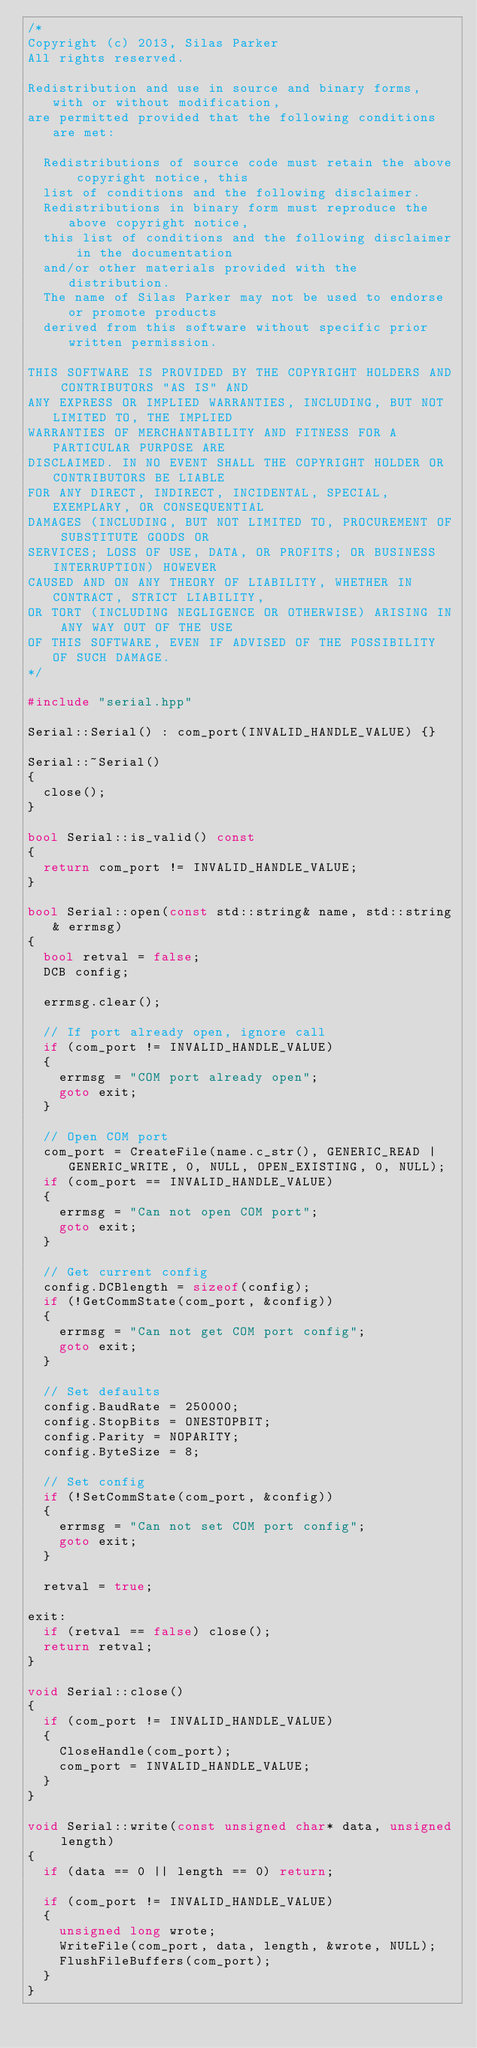Convert code to text. <code><loc_0><loc_0><loc_500><loc_500><_C++_>/*
Copyright (c) 2013, Silas Parker
All rights reserved.

Redistribution and use in source and binary forms, with or without modification,
are permitted provided that the following conditions are met:

	Redistributions of source code must retain the above copyright notice, this
	list of conditions and the following disclaimer.
	Redistributions in binary form must reproduce the above copyright notice,
	this list of conditions and the following disclaimer in the documentation
	and/or other materials provided with the distribution.
	The name of Silas Parker may not be used to endorse or promote products
	derived from this software without specific prior written permission.

THIS SOFTWARE IS PROVIDED BY THE COPYRIGHT HOLDERS AND CONTRIBUTORS "AS IS" AND
ANY EXPRESS OR IMPLIED WARRANTIES, INCLUDING, BUT NOT LIMITED TO, THE IMPLIED
WARRANTIES OF MERCHANTABILITY AND FITNESS FOR A PARTICULAR PURPOSE ARE
DISCLAIMED. IN NO EVENT SHALL THE COPYRIGHT HOLDER OR CONTRIBUTORS BE LIABLE
FOR ANY DIRECT, INDIRECT, INCIDENTAL, SPECIAL, EXEMPLARY, OR CONSEQUENTIAL
DAMAGES (INCLUDING, BUT NOT LIMITED TO, PROCUREMENT OF SUBSTITUTE GOODS OR
SERVICES; LOSS OF USE, DATA, OR PROFITS; OR BUSINESS INTERRUPTION) HOWEVER
CAUSED AND ON ANY THEORY OF LIABILITY, WHETHER IN CONTRACT, STRICT LIABILITY,
OR TORT (INCLUDING NEGLIGENCE OR OTHERWISE) ARISING IN ANY WAY OUT OF THE USE
OF THIS SOFTWARE, EVEN IF ADVISED OF THE POSSIBILITY OF SUCH DAMAGE.
*/

#include "serial.hpp"

Serial::Serial() : com_port(INVALID_HANDLE_VALUE) {}

Serial::~Serial()
{
	close();
}

bool Serial::is_valid() const
{
	return com_port != INVALID_HANDLE_VALUE;
}

bool Serial::open(const std::string& name, std::string& errmsg)
{
	bool retval = false;
	DCB config;

	errmsg.clear();

	// If port already open, ignore call
	if (com_port != INVALID_HANDLE_VALUE)
	{
		errmsg = "COM port already open";
		goto exit;
	}

	// Open COM port
	com_port = CreateFile(name.c_str(), GENERIC_READ | GENERIC_WRITE, 0, NULL, OPEN_EXISTING, 0, NULL);
	if (com_port == INVALID_HANDLE_VALUE)
	{
		errmsg = "Can not open COM port";
		goto exit;
	}

	// Get current config
	config.DCBlength = sizeof(config);
	if (!GetCommState(com_port, &config))
	{
		errmsg = "Can not get COM port config";
		goto exit;
	}

	// Set defaults
	config.BaudRate = 250000;
	config.StopBits = ONESTOPBIT;
	config.Parity = NOPARITY;
	config.ByteSize = 8;

	// Set config
	if (!SetCommState(com_port, &config))
	{
		errmsg = "Can not set COM port config";
		goto exit;
	}

	retval = true;

exit:
	if (retval == false) close();
	return retval;
}

void Serial::close()
{
	if (com_port != INVALID_HANDLE_VALUE)
	{
		CloseHandle(com_port);
		com_port = INVALID_HANDLE_VALUE;
	}
}

void Serial::write(const unsigned char* data, unsigned length)
{
	if (data == 0 || length == 0) return;

	if (com_port != INVALID_HANDLE_VALUE)
	{
		unsigned long wrote;
		WriteFile(com_port, data, length, &wrote, NULL);
		FlushFileBuffers(com_port);
	}
}
</code> 